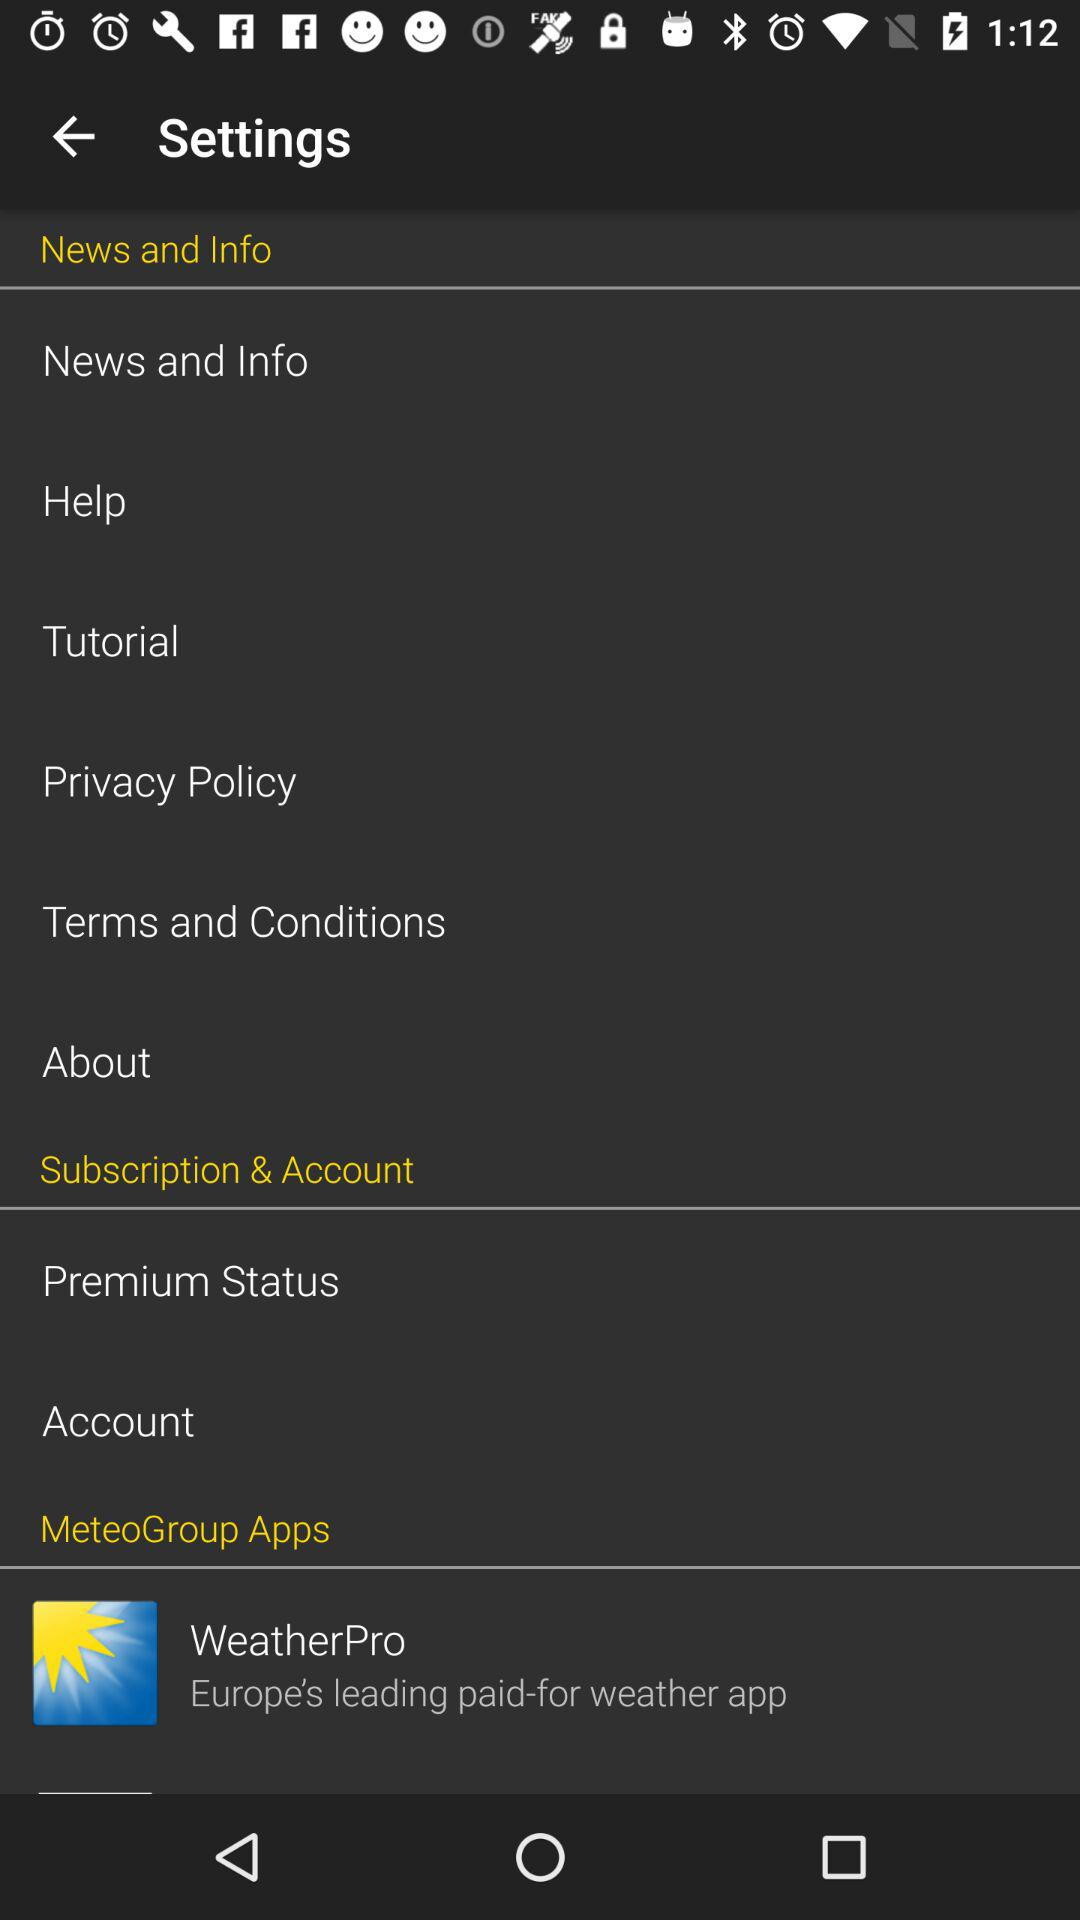What is the name of the application? The name of the application is "WeatherPro". 